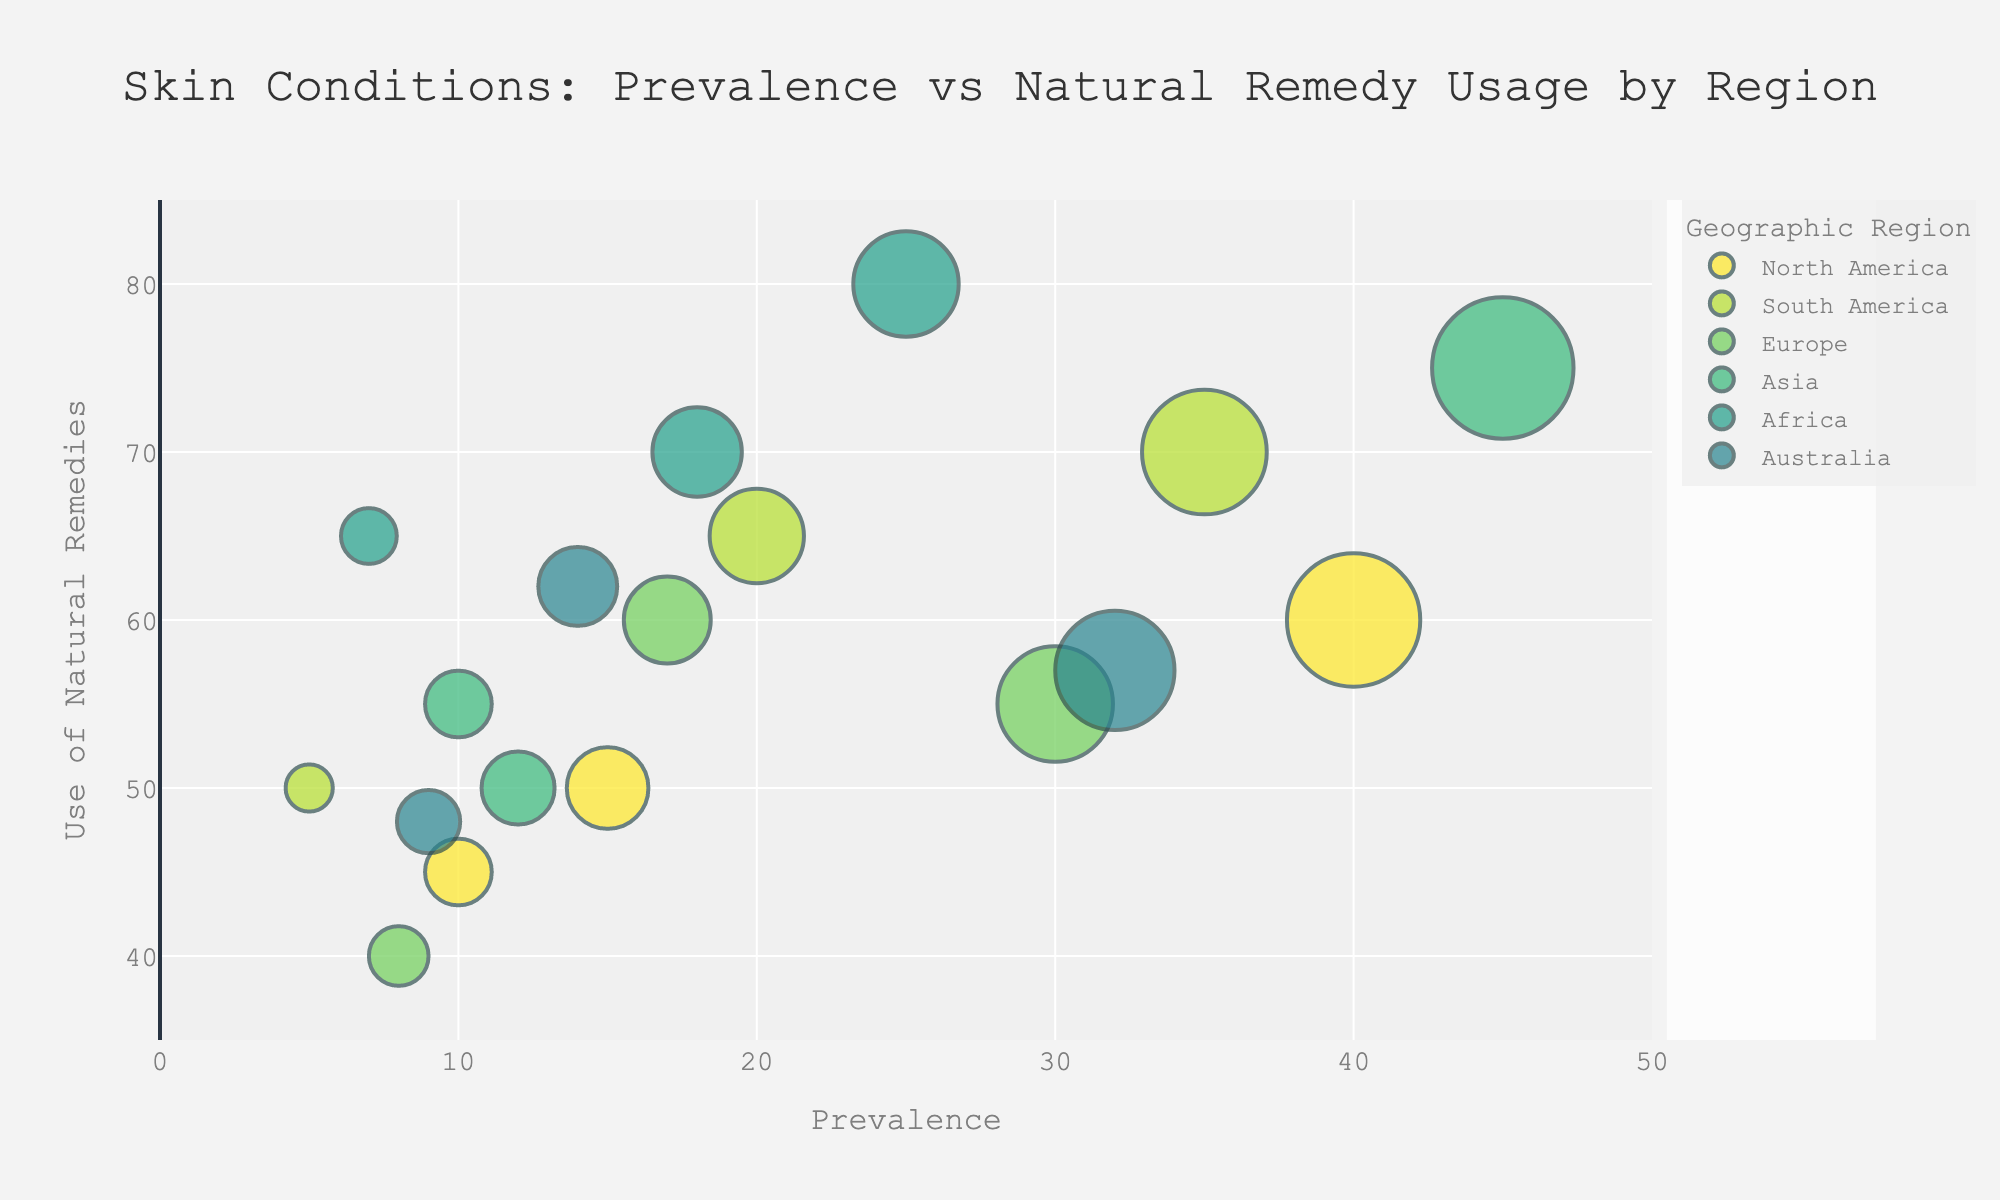What's the title of the figure? The title is displayed at the top center of the figure.
Answer: Skin Conditions: Prevalence vs Natural Remedy Usage by Region How many skin conditions are represented from each geographic region? Each region has three skin conditions represented, identified by hovering over the data points.
Answer: Three What geographic region has the highest use of natural remedies for Eczema? Locate the bubble for Eczema and compare the y-axis value (Use of Natural Remedies) across different regions. The highest is in Africa.
Answer: Africa Which skin condition has the highest prevalence in the figure? Look at the x-axis (Prevalence) and identify the bubble with the highest value. This is Acne in Asia with a prevalence of 45%.
Answer: Acne in Asia Which region has the highest average use of natural remedies for all skin conditions combined? Calculate the average of the y-axis values (Use of Natural Remedies) for each region and compare them. Africa has the highest average (75+70+65)/3 = 70%.
Answer: Africa Is the use of natural remedies for Acne higher in South America or North America? Compare the y-axis values (Use of Natural Remedies) for Acne in South America and North America. South America has a higher value of 70% compared to North America's 60%.
Answer: South America What is the difference in prevalence between Psoriasis in Asia and North America? Subtract the x-axis value (Prevalence) of Psoriasis in North America from the x-axis value in Asia. The prevalence in Asia is 12% and in North America is 10%, so the difference is 2%.
Answer: 2% Is there any skin condition in Australia with a prevalence greater than 30%? Look at the x-axis values (Prevalence) for skin conditions in Australia and check if any are above 30%. Acne has a prevalence of 32%.
Answer: Yes Which skin condition in Europe has the highest use of natural remedies? Compare the y-axis values (Use of Natural Remedies) for skin conditions in Europe. Eczema has the highest value at 60%.
Answer: Eczema How does the use of natural remedies for Psoriasis in Africa compare to North America? Compare the y-axis values (Use of Natural Remedies) for Psoriasis in Africa and North America. Africa has a higher value of 65% compared to North America's 45%.
Answer: Higher 